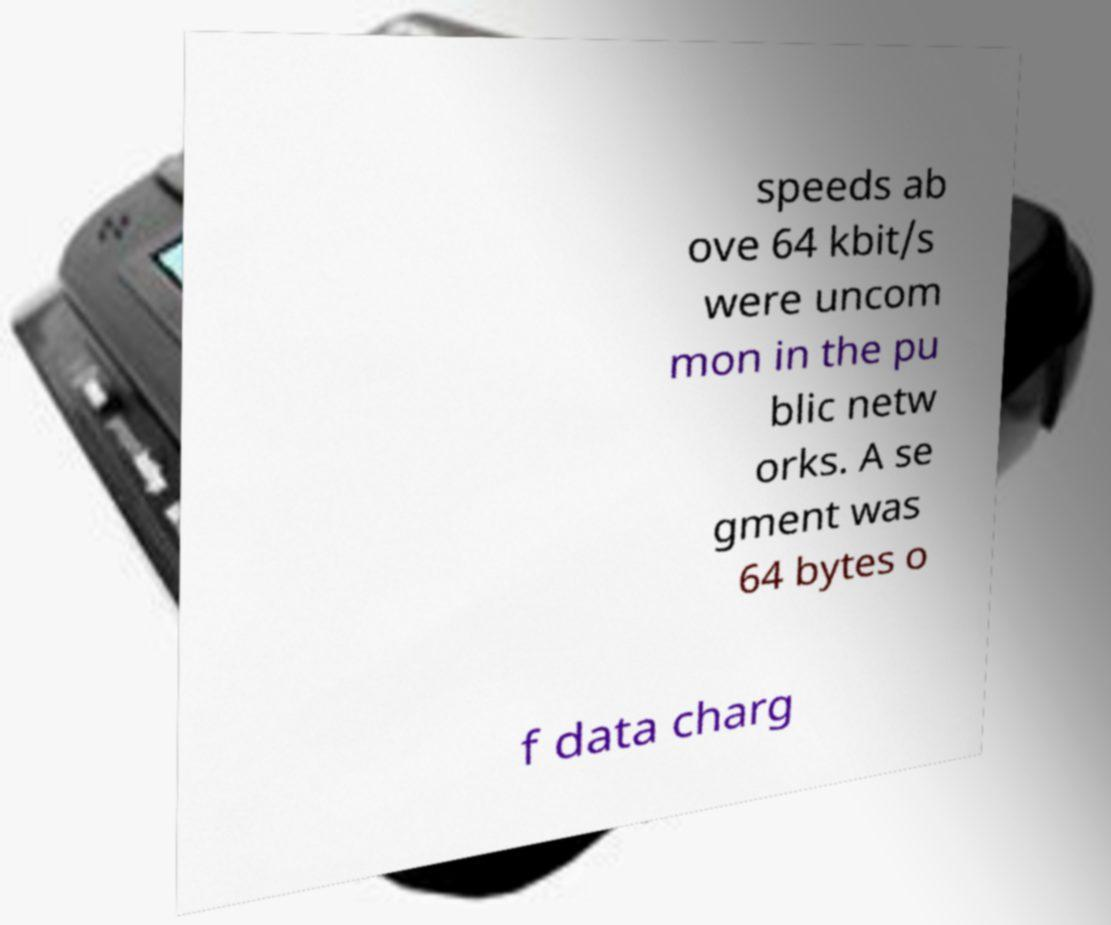Could you extract and type out the text from this image? speeds ab ove 64 kbit/s were uncom mon in the pu blic netw orks. A se gment was 64 bytes o f data charg 